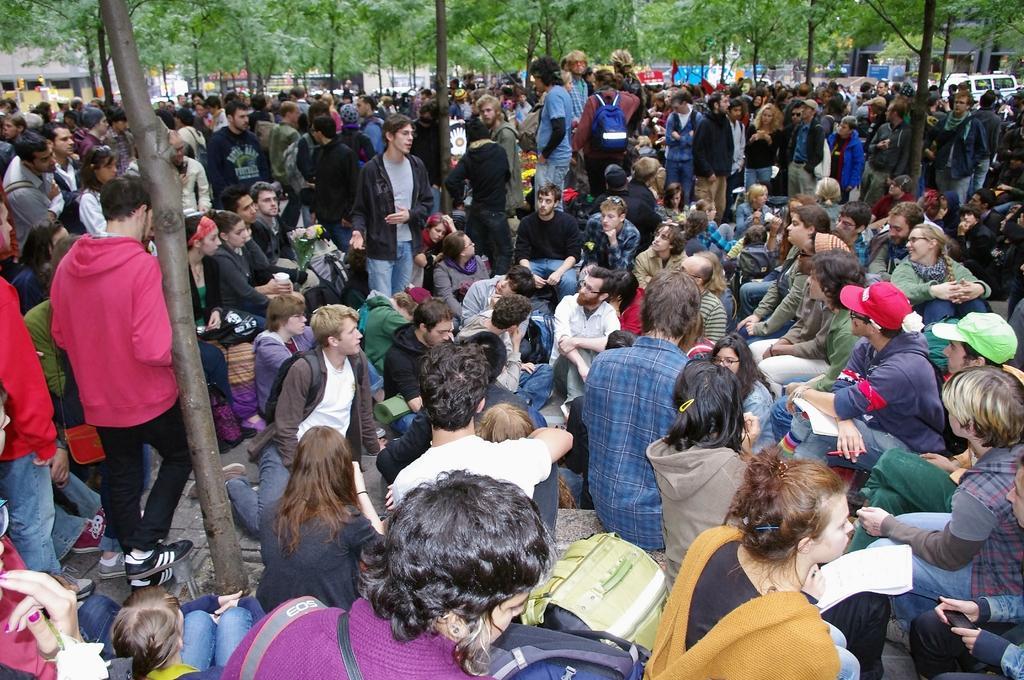In one or two sentences, can you explain what this image depicts? In this picture there is a group of men and women sitting on the ground and listening to the man. In the center there is a man wearing black t-shirt is giving a speech. In the background we can see a group of persons are standing and some trees. 